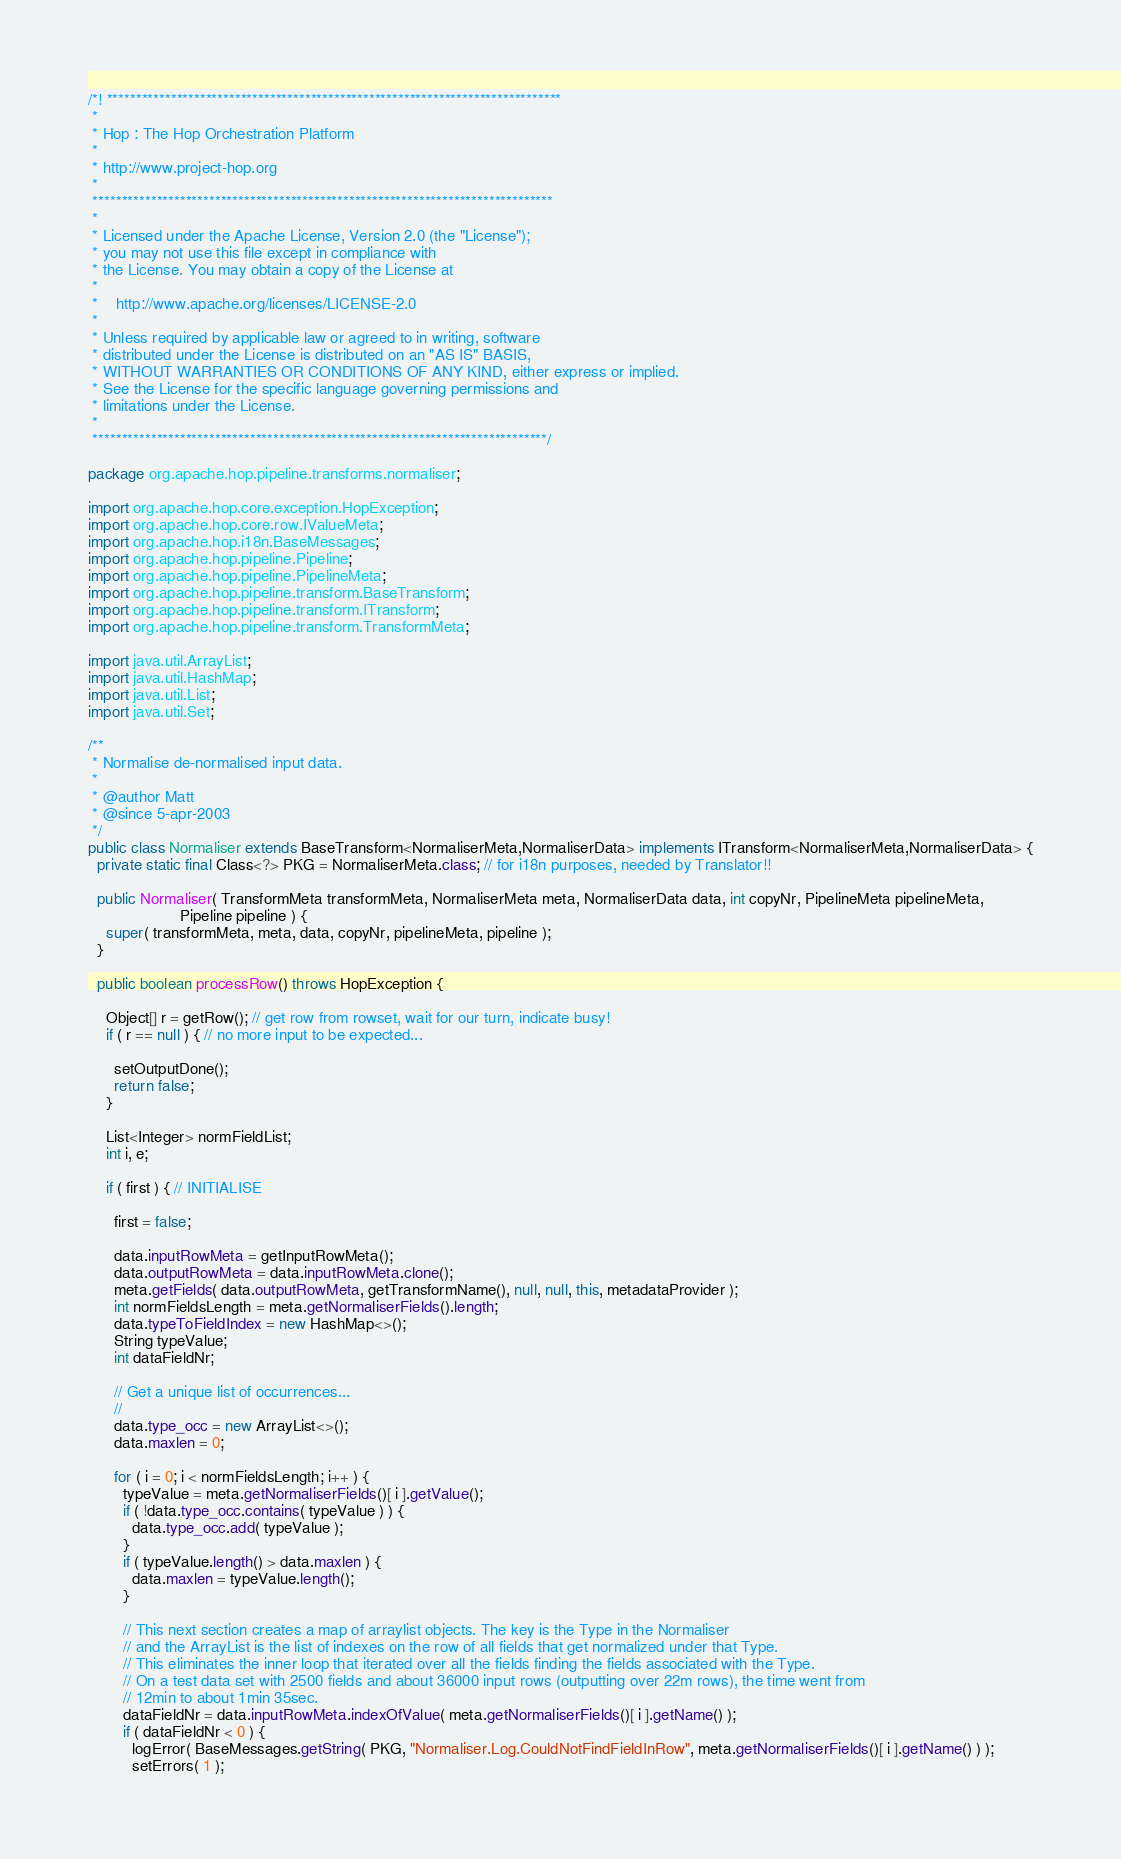<code> <loc_0><loc_0><loc_500><loc_500><_Java_>/*! ******************************************************************************
 *
 * Hop : The Hop Orchestration Platform
 *
 * http://www.project-hop.org
 *
 *******************************************************************************
 *
 * Licensed under the Apache License, Version 2.0 (the "License");
 * you may not use this file except in compliance with
 * the License. You may obtain a copy of the License at
 *
 *    http://www.apache.org/licenses/LICENSE-2.0
 *
 * Unless required by applicable law or agreed to in writing, software
 * distributed under the License is distributed on an "AS IS" BASIS,
 * WITHOUT WARRANTIES OR CONDITIONS OF ANY KIND, either express or implied.
 * See the License for the specific language governing permissions and
 * limitations under the License.
 *
 ******************************************************************************/

package org.apache.hop.pipeline.transforms.normaliser;

import org.apache.hop.core.exception.HopException;
import org.apache.hop.core.row.IValueMeta;
import org.apache.hop.i18n.BaseMessages;
import org.apache.hop.pipeline.Pipeline;
import org.apache.hop.pipeline.PipelineMeta;
import org.apache.hop.pipeline.transform.BaseTransform;
import org.apache.hop.pipeline.transform.ITransform;
import org.apache.hop.pipeline.transform.TransformMeta;

import java.util.ArrayList;
import java.util.HashMap;
import java.util.List;
import java.util.Set;

/**
 * Normalise de-normalised input data.
 *
 * @author Matt
 * @since 5-apr-2003
 */
public class Normaliser extends BaseTransform<NormaliserMeta,NormaliserData> implements ITransform<NormaliserMeta,NormaliserData> {
  private static final Class<?> PKG = NormaliserMeta.class; // for i18n purposes, needed by Translator!!

  public Normaliser( TransformMeta transformMeta, NormaliserMeta meta, NormaliserData data, int copyNr, PipelineMeta pipelineMeta,
                     Pipeline pipeline ) {
    super( transformMeta, meta, data, copyNr, pipelineMeta, pipeline );
  }

  public boolean processRow() throws HopException {

    Object[] r = getRow(); // get row from rowset, wait for our turn, indicate busy!
    if ( r == null ) { // no more input to be expected...

      setOutputDone();
      return false;
    }

    List<Integer> normFieldList;
    int i, e;

    if ( first ) { // INITIALISE

      first = false;

      data.inputRowMeta = getInputRowMeta();
      data.outputRowMeta = data.inputRowMeta.clone();
      meta.getFields( data.outputRowMeta, getTransformName(), null, null, this, metadataProvider );
      int normFieldsLength = meta.getNormaliserFields().length;
      data.typeToFieldIndex = new HashMap<>();
      String typeValue;
      int dataFieldNr;

      // Get a unique list of occurrences...
      //
      data.type_occ = new ArrayList<>();
      data.maxlen = 0;

      for ( i = 0; i < normFieldsLength; i++ ) {
        typeValue = meta.getNormaliserFields()[ i ].getValue();
        if ( !data.type_occ.contains( typeValue ) ) {
          data.type_occ.add( typeValue );
        }
        if ( typeValue.length() > data.maxlen ) {
          data.maxlen = typeValue.length();
        }

        // This next section creates a map of arraylist objects. The key is the Type in the Normaliser
        // and the ArrayList is the list of indexes on the row of all fields that get normalized under that Type.
        // This eliminates the inner loop that iterated over all the fields finding the fields associated with the Type.
        // On a test data set with 2500 fields and about 36000 input rows (outputting over 22m rows), the time went from
        // 12min to about 1min 35sec.
        dataFieldNr = data.inputRowMeta.indexOfValue( meta.getNormaliserFields()[ i ].getName() );
        if ( dataFieldNr < 0 ) {
          logError( BaseMessages.getString( PKG, "Normaliser.Log.CouldNotFindFieldInRow", meta.getNormaliserFields()[ i ].getName() ) );
          setErrors( 1 );</code> 